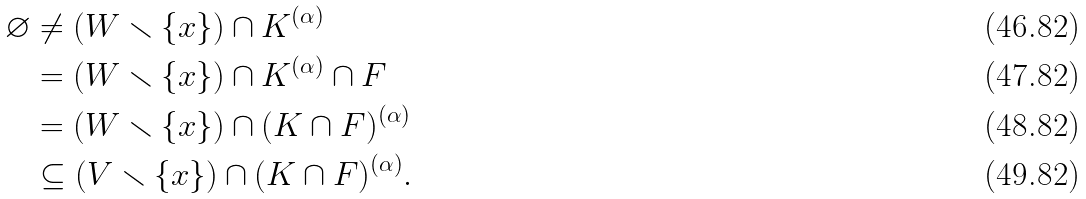<formula> <loc_0><loc_0><loc_500><loc_500>\varnothing & \neq \left ( W \smallsetminus \{ x \} \right ) \cap K ^ { ( \alpha ) } \\ & = \left ( W \smallsetminus \{ x \} \right ) \cap K ^ { ( \alpha ) } \cap F \\ & = \left ( W \smallsetminus \{ x \} \right ) \cap ( K \cap F ) ^ { ( \alpha ) } \\ & \subseteq \left ( V \smallsetminus \{ x \} \right ) \cap ( K \cap F ) ^ { ( \alpha ) } .</formula> 